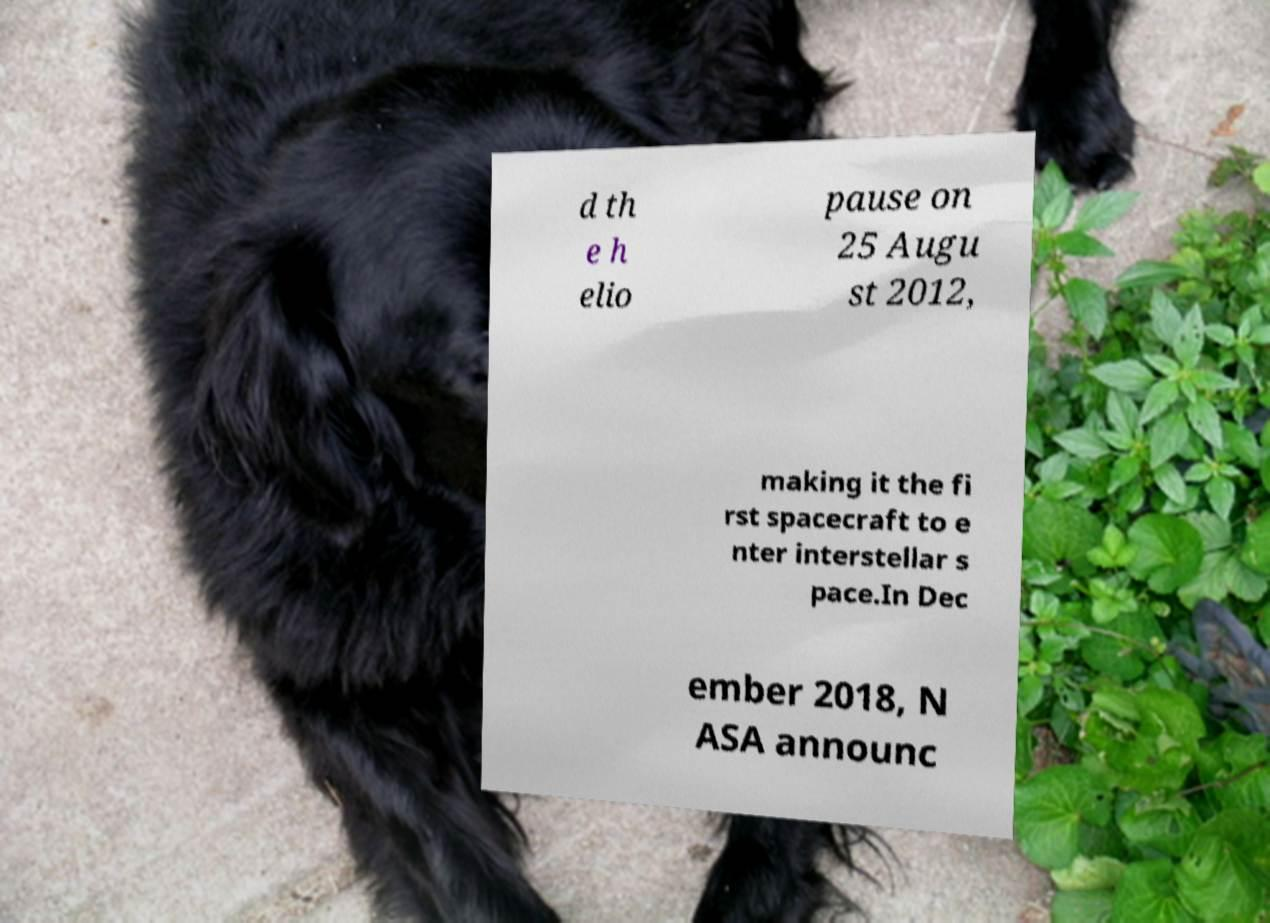Can you accurately transcribe the text from the provided image for me? d th e h elio pause on 25 Augu st 2012, making it the fi rst spacecraft to e nter interstellar s pace.In Dec ember 2018, N ASA announc 